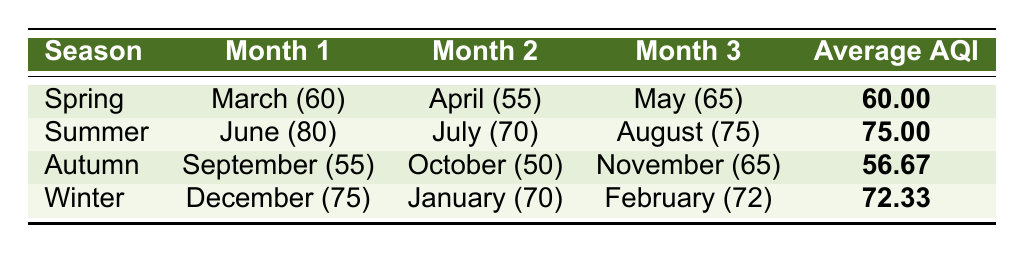What is the average AQI for Spring in Ranchi? The table shows that the average AQI for Spring is listed as 60.
Answer: 60 Which season has the highest average AQI? By comparing the average AQIs for each season, Summer has the highest average AQI at 75.
Answer: 75 What was the Average AQI in July? The table indicates that the Average AQI in July is 70.
Answer: 70 Is the average AQI in Autumn higher than Winter? The average AQI for Autumn is 56.67 and for Winter is 72.33. Since 56.67 is less than 72.33, the statement is false.
Answer: No What is the difference between the average AQI of Summer and Autumn? The average AQI for Summer is 75 and for Autumn is 56.67. The difference is calculated as 75 - 56.67 = 18.33.
Answer: 18.33 Which month in Winter had the lowest AQI? In Winter, the months are December (75), January (70), and February (72). January has the lowest AQI at 70.
Answer: January What is the overall average AQI for all seasons combined? To find the overall average AQI, sum the seasonal averages: 60 (Spring) + 75 (Summer) + 56.67 (Autumn) + 72.33 (Winter) = 264.67. Then divide by 4: 264.67 / 4 = 66.167.
Answer: 66.17 Does August have a higher AQI than March? In August, the AQI is 75 while in March it is 60. Since 75 is greater than 60, the statement is true.
Answer: Yes In which season does the month of September fall? The table indicates that September is in the Autumn season.
Answer: Autumn 